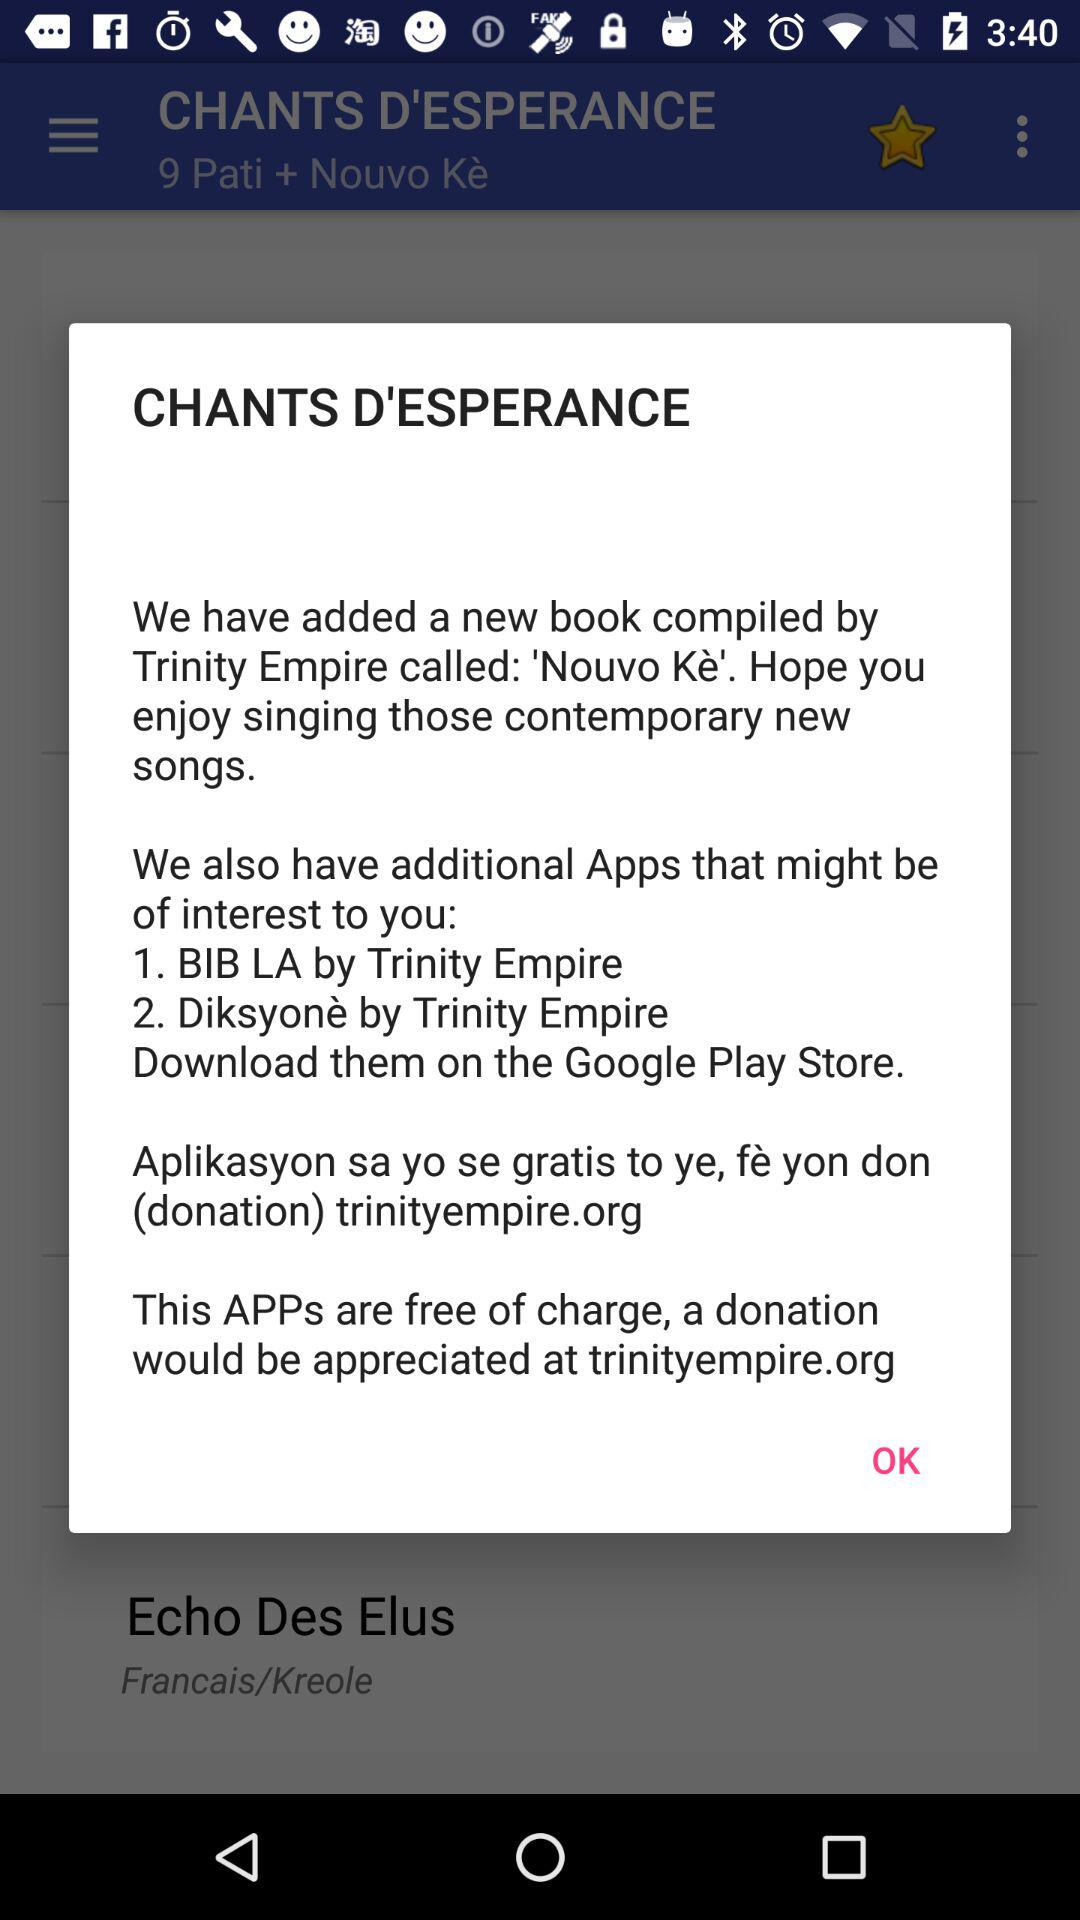Are these apps free or paid? These apps are "free of charge". 